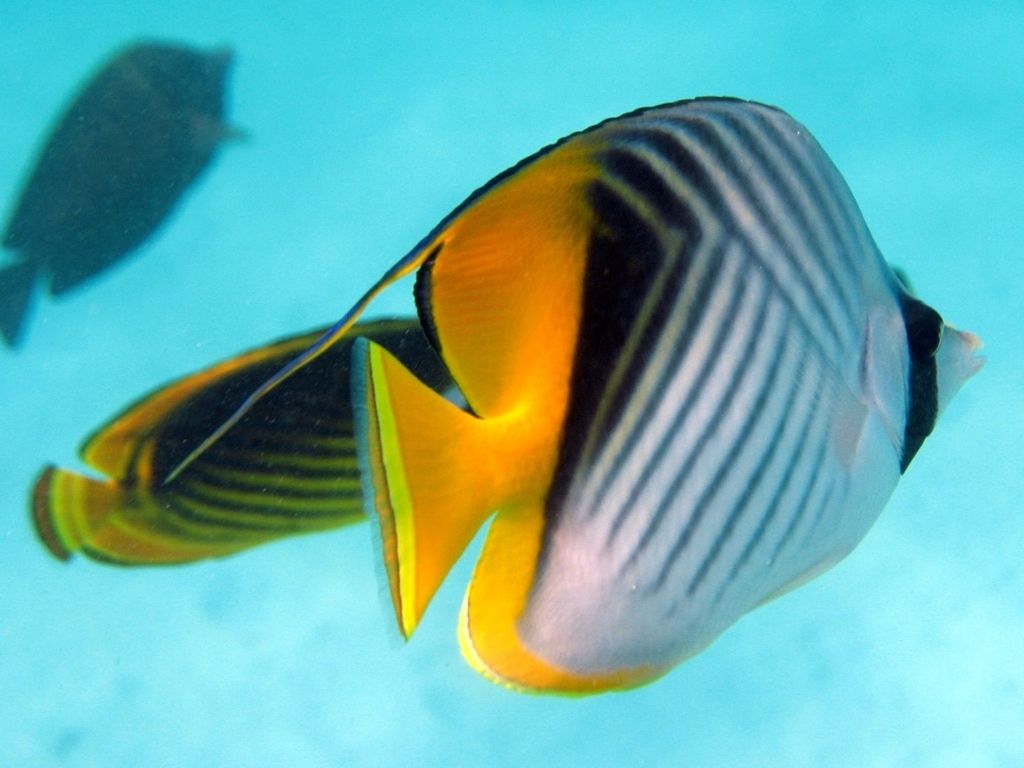Describe the way the light interacts with the fish and the water. The interplay of light in this image is captivating, with natural sunlight filtering through the water and spotlighting the fish. This illumination creates a play of light and shadow that accentuates the curves and outlines of the fish's body. It also adds a sense of depth to the water and brings a shimmering quality to the scales, which is a testament to the photographer's ability to capture such detail in motion. Furthermore, the light's diffusion in the water generates a bokeh effect in the background, which is visually pleasing and focuses the viewer's attention on the fish. 